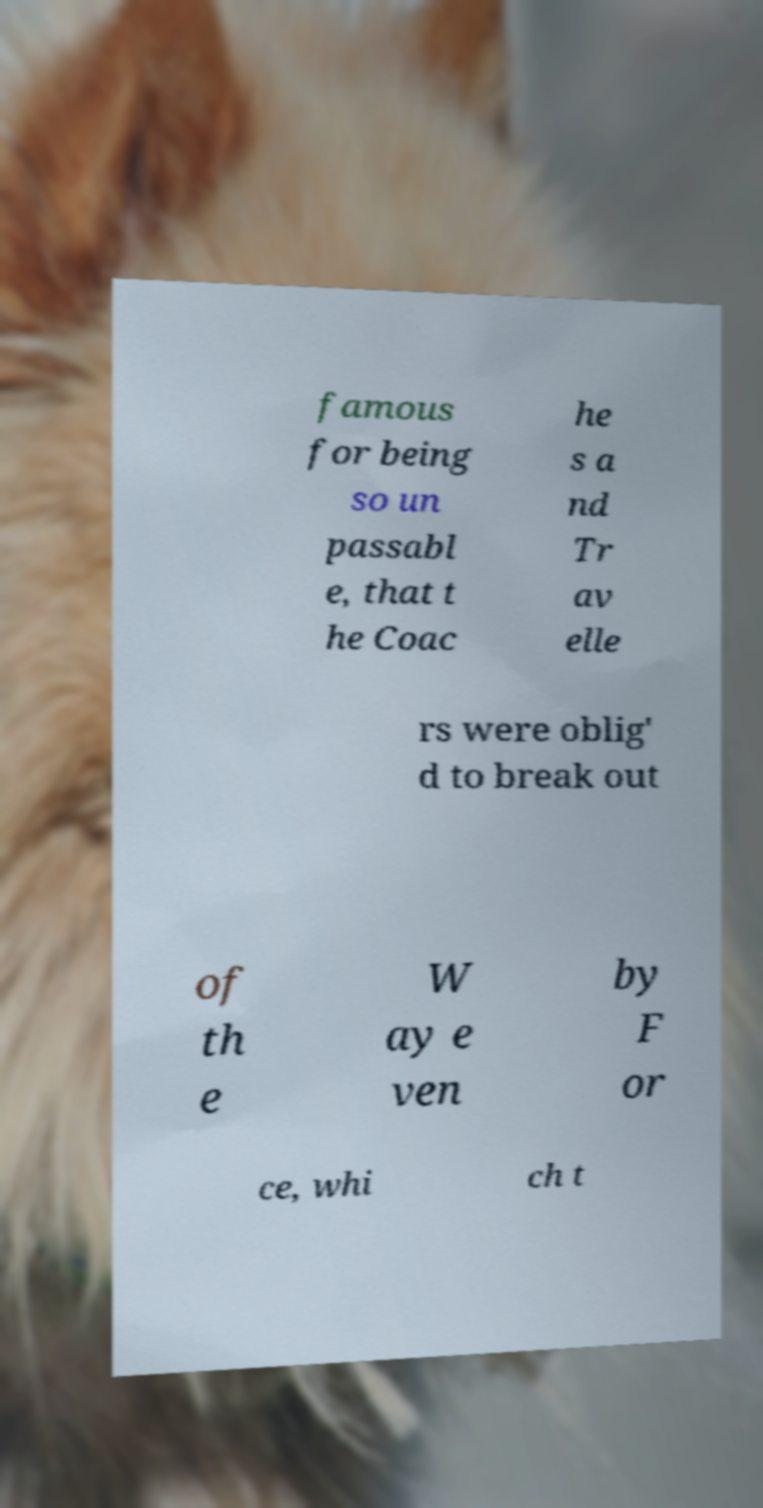There's text embedded in this image that I need extracted. Can you transcribe it verbatim? famous for being so un passabl e, that t he Coac he s a nd Tr av elle rs were oblig' d to break out of th e W ay e ven by F or ce, whi ch t 